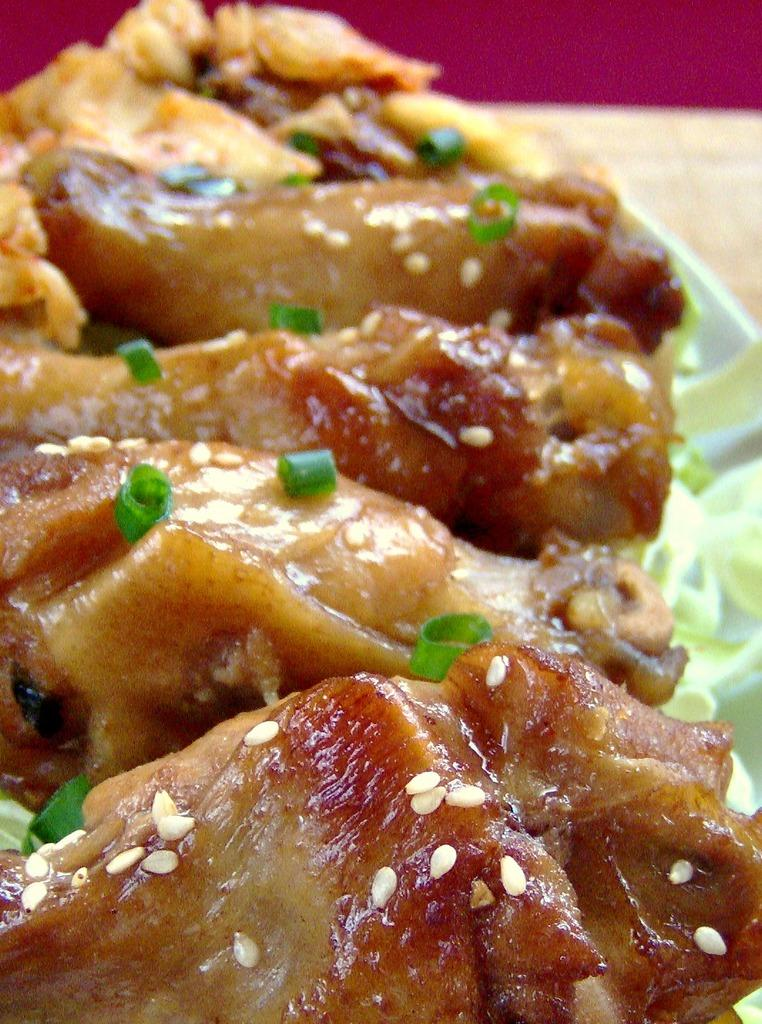What is present on the plate in the image? There are food items on a plate in the image. What type of design can be seen on the clover in the image? There is no clover present in the image; it features food items on a plate. 